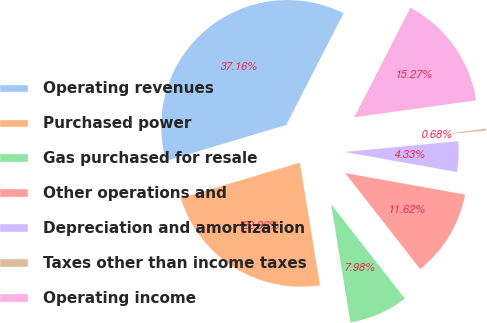<chart> <loc_0><loc_0><loc_500><loc_500><pie_chart><fcel>Operating revenues<fcel>Purchased power<fcel>Gas purchased for resale<fcel>Other operations and<fcel>Depreciation and amortization<fcel>Taxes other than income taxes<fcel>Operating income<nl><fcel>37.16%<fcel>22.96%<fcel>7.98%<fcel>11.62%<fcel>4.33%<fcel>0.68%<fcel>15.27%<nl></chart> 